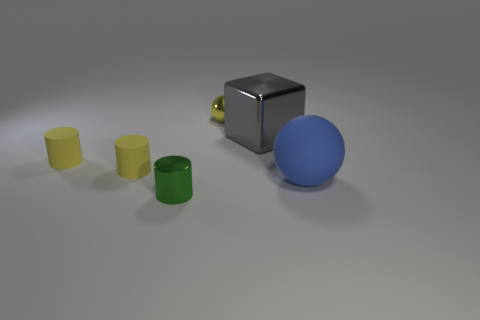There is a green metallic cylinder; what number of small green metal objects are behind it?
Offer a very short reply. 0. What number of matte objects have the same color as the metallic ball?
Keep it short and to the point. 2. How many objects are either small cylinders on the left side of the tiny green metallic object or cylinders that are to the left of the small green cylinder?
Your answer should be compact. 2. Are there more large cubes than tiny yellow matte things?
Give a very brief answer. No. There is a object behind the gray block; what color is it?
Offer a terse response. Yellow. Do the big gray thing and the small yellow shiny thing have the same shape?
Make the answer very short. No. What is the color of the object that is on the right side of the metal cylinder and on the left side of the large gray thing?
Your answer should be compact. Yellow. There is a thing to the right of the gray cube; is its size the same as the cylinder in front of the big sphere?
Make the answer very short. No. What number of objects are either balls that are behind the big blue matte ball or big brown rubber blocks?
Your answer should be very brief. 1. What is the green cylinder made of?
Provide a short and direct response. Metal. 